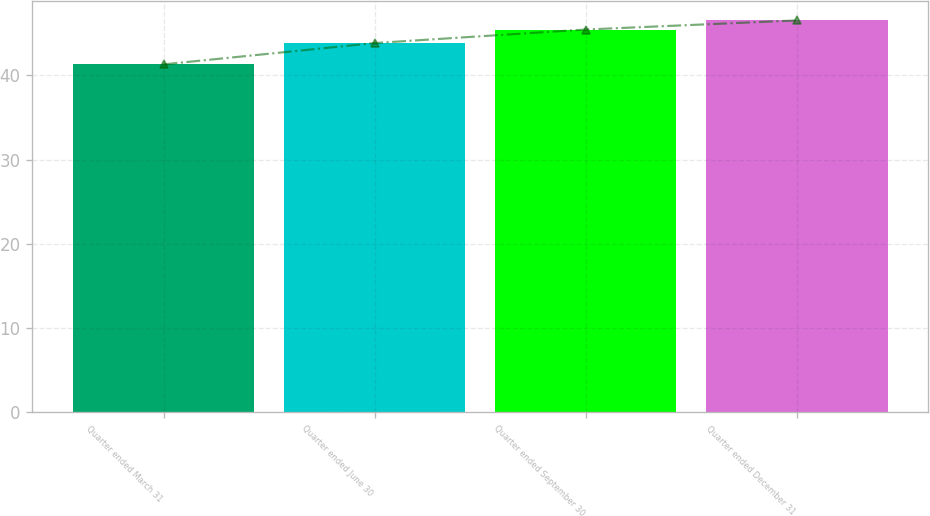<chart> <loc_0><loc_0><loc_500><loc_500><bar_chart><fcel>Quarter ended March 31<fcel>Quarter ended June 30<fcel>Quarter ended September 30<fcel>Quarter ended December 31<nl><fcel>41.31<fcel>43.84<fcel>45.45<fcel>46.53<nl></chart> 